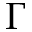Convert formula to latex. <formula><loc_0><loc_0><loc_500><loc_500>\Gamma</formula> 